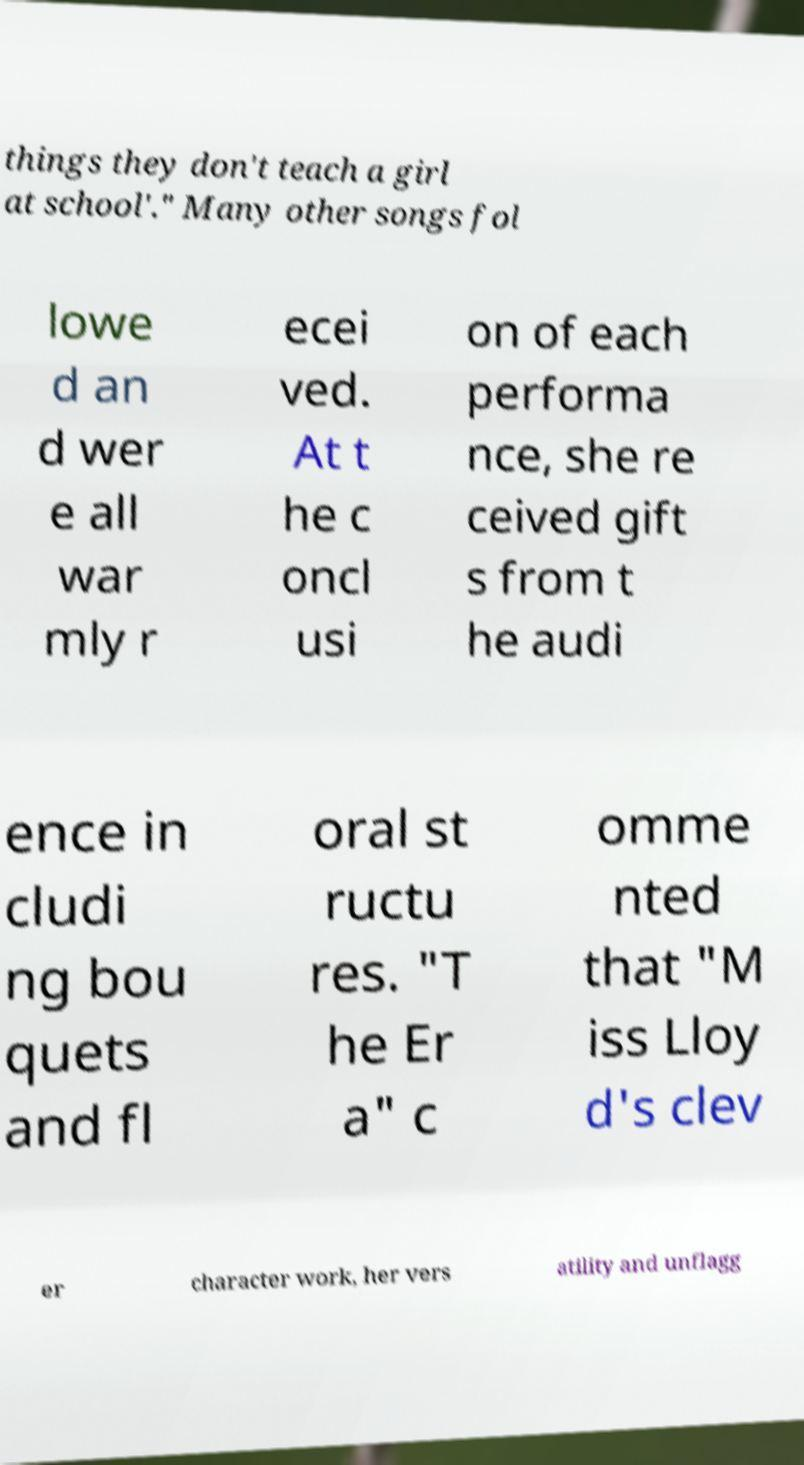Can you accurately transcribe the text from the provided image for me? things they don't teach a girl at school'." Many other songs fol lowe d an d wer e all war mly r ecei ved. At t he c oncl usi on of each performa nce, she re ceived gift s from t he audi ence in cludi ng bou quets and fl oral st ructu res. "T he Er a" c omme nted that "M iss Lloy d's clev er character work, her vers atility and unflagg 